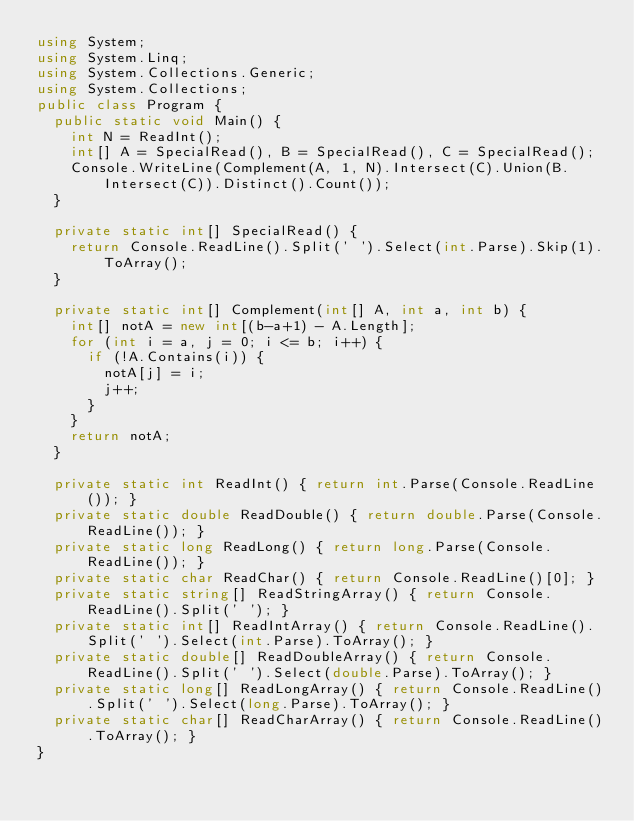Convert code to text. <code><loc_0><loc_0><loc_500><loc_500><_C#_>using System;
using System.Linq;
using System.Collections.Generic;
using System.Collections;
public class Program {
  public static void Main() {
    int N = ReadInt();
    int[] A = SpecialRead(), B = SpecialRead(), C = SpecialRead();
    Console.WriteLine(Complement(A, 1, N).Intersect(C).Union(B.Intersect(C)).Distinct().Count());
  }

  private static int[] SpecialRead() {
    return Console.ReadLine().Split(' ').Select(int.Parse).Skip(1).ToArray();
  }

  private static int[] Complement(int[] A, int a, int b) {
    int[] notA = new int[(b-a+1) - A.Length];
    for (int i = a, j = 0; i <= b; i++) {
      if (!A.Contains(i)) {
        notA[j] = i;
        j++;
      }
    }
    return notA;
  }

  private static int ReadInt() { return int.Parse(Console.ReadLine()); }
  private static double ReadDouble() { return double.Parse(Console.ReadLine()); }
  private static long ReadLong() { return long.Parse(Console.ReadLine()); }
  private static char ReadChar() { return Console.ReadLine()[0]; }
  private static string[] ReadStringArray() { return Console.ReadLine().Split(' '); }
  private static int[] ReadIntArray() { return Console.ReadLine().Split(' ').Select(int.Parse).ToArray(); }
  private static double[] ReadDoubleArray() { return Console.ReadLine().Split(' ').Select(double.Parse).ToArray(); }
  private static long[] ReadLongArray() { return Console.ReadLine().Split(' ').Select(long.Parse).ToArray(); }
  private static char[] ReadCharArray() { return Console.ReadLine().ToArray(); }
}

</code> 